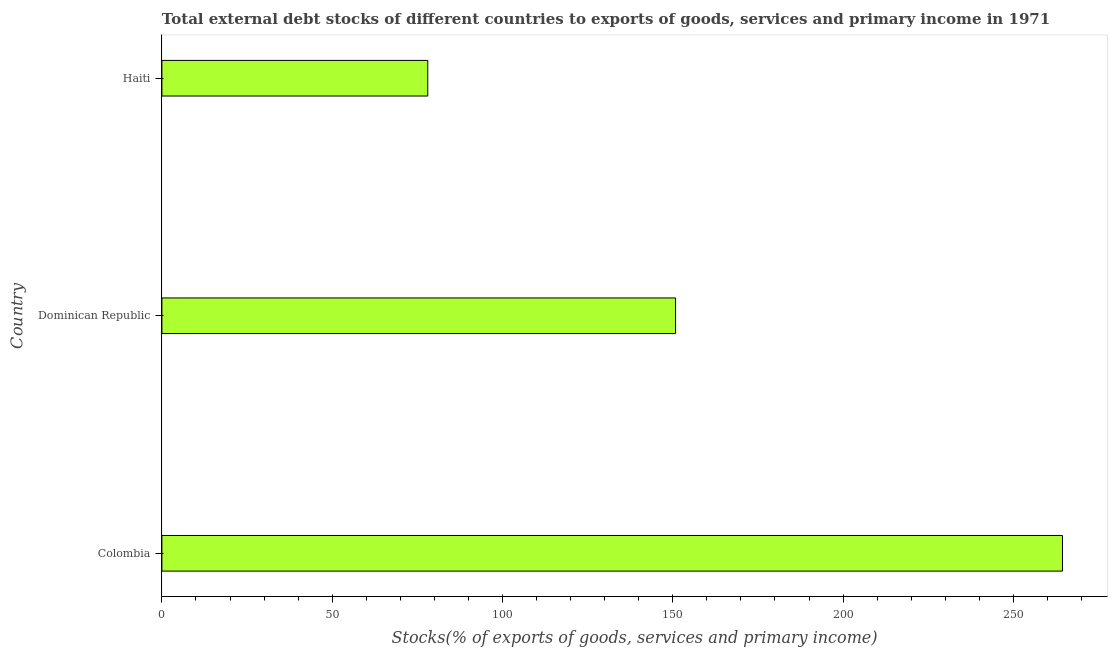What is the title of the graph?
Your answer should be compact. Total external debt stocks of different countries to exports of goods, services and primary income in 1971. What is the label or title of the X-axis?
Provide a short and direct response. Stocks(% of exports of goods, services and primary income). What is the label or title of the Y-axis?
Provide a succinct answer. Country. What is the external debt stocks in Colombia?
Give a very brief answer. 264.42. Across all countries, what is the maximum external debt stocks?
Offer a very short reply. 264.42. Across all countries, what is the minimum external debt stocks?
Provide a succinct answer. 78.06. In which country was the external debt stocks maximum?
Give a very brief answer. Colombia. In which country was the external debt stocks minimum?
Make the answer very short. Haiti. What is the sum of the external debt stocks?
Provide a short and direct response. 493.3. What is the difference between the external debt stocks in Colombia and Haiti?
Your answer should be compact. 186.36. What is the average external debt stocks per country?
Offer a very short reply. 164.43. What is the median external debt stocks?
Make the answer very short. 150.82. In how many countries, is the external debt stocks greater than 50 %?
Your answer should be very brief. 3. What is the ratio of the external debt stocks in Dominican Republic to that in Haiti?
Your answer should be compact. 1.93. Is the external debt stocks in Colombia less than that in Haiti?
Offer a very short reply. No. Is the difference between the external debt stocks in Colombia and Haiti greater than the difference between any two countries?
Provide a succinct answer. Yes. What is the difference between the highest and the second highest external debt stocks?
Keep it short and to the point. 113.6. What is the difference between the highest and the lowest external debt stocks?
Provide a succinct answer. 186.36. In how many countries, is the external debt stocks greater than the average external debt stocks taken over all countries?
Your answer should be compact. 1. Are all the bars in the graph horizontal?
Your answer should be very brief. Yes. How many countries are there in the graph?
Offer a very short reply. 3. What is the Stocks(% of exports of goods, services and primary income) of Colombia?
Your answer should be very brief. 264.42. What is the Stocks(% of exports of goods, services and primary income) in Dominican Republic?
Offer a very short reply. 150.82. What is the Stocks(% of exports of goods, services and primary income) in Haiti?
Your answer should be compact. 78.06. What is the difference between the Stocks(% of exports of goods, services and primary income) in Colombia and Dominican Republic?
Offer a terse response. 113.6. What is the difference between the Stocks(% of exports of goods, services and primary income) in Colombia and Haiti?
Ensure brevity in your answer.  186.36. What is the difference between the Stocks(% of exports of goods, services and primary income) in Dominican Republic and Haiti?
Ensure brevity in your answer.  72.76. What is the ratio of the Stocks(% of exports of goods, services and primary income) in Colombia to that in Dominican Republic?
Make the answer very short. 1.75. What is the ratio of the Stocks(% of exports of goods, services and primary income) in Colombia to that in Haiti?
Ensure brevity in your answer.  3.39. What is the ratio of the Stocks(% of exports of goods, services and primary income) in Dominican Republic to that in Haiti?
Provide a short and direct response. 1.93. 